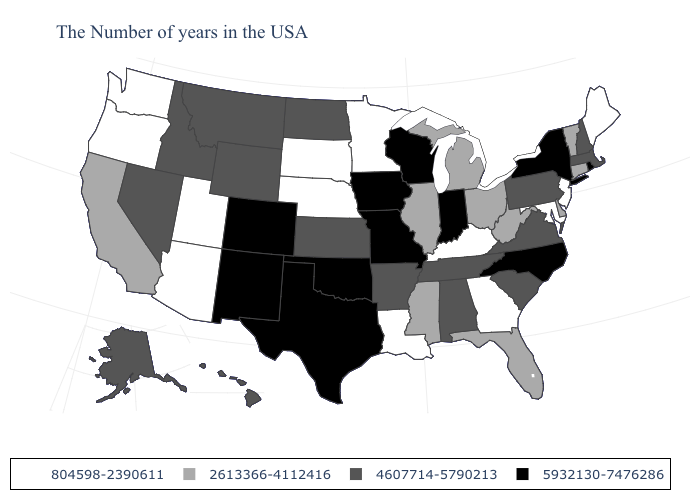How many symbols are there in the legend?
Quick response, please. 4. What is the highest value in the USA?
Quick response, please. 5932130-7476286. What is the value of Nebraska?
Be succinct. 804598-2390611. What is the lowest value in states that border Utah?
Short answer required. 804598-2390611. What is the value of Minnesota?
Concise answer only. 804598-2390611. What is the value of Arkansas?
Be succinct. 4607714-5790213. What is the highest value in the USA?
Short answer required. 5932130-7476286. Does Indiana have a higher value than Missouri?
Be succinct. No. What is the value of Rhode Island?
Quick response, please. 5932130-7476286. What is the highest value in the West ?
Quick response, please. 5932130-7476286. What is the lowest value in the Northeast?
Write a very short answer. 804598-2390611. Which states hav the highest value in the MidWest?
Keep it brief. Indiana, Wisconsin, Missouri, Iowa. Name the states that have a value in the range 804598-2390611?
Concise answer only. Maine, New Jersey, Maryland, Georgia, Kentucky, Louisiana, Minnesota, Nebraska, South Dakota, Utah, Arizona, Washington, Oregon. Name the states that have a value in the range 804598-2390611?
Keep it brief. Maine, New Jersey, Maryland, Georgia, Kentucky, Louisiana, Minnesota, Nebraska, South Dakota, Utah, Arizona, Washington, Oregon. What is the highest value in the Northeast ?
Be succinct. 5932130-7476286. 